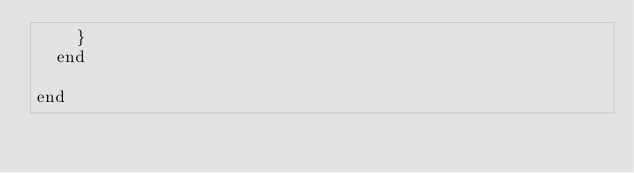<code> <loc_0><loc_0><loc_500><loc_500><_Elixir_>    }
  end

end
</code> 